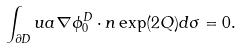<formula> <loc_0><loc_0><loc_500><loc_500>\int _ { \partial D } u a \nabla \phi _ { 0 } ^ { D } \cdot n \exp ( 2 Q ) d \sigma = 0 .</formula> 